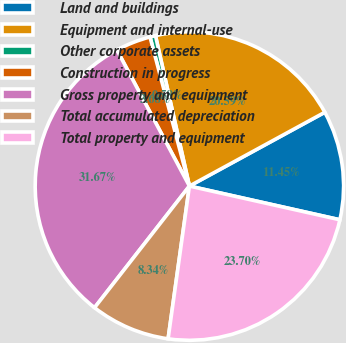Convert chart to OTSL. <chart><loc_0><loc_0><loc_500><loc_500><pie_chart><fcel>Land and buildings<fcel>Equipment and internal-use<fcel>Other corporate assets<fcel>Construction in progress<fcel>Gross property and equipment<fcel>Total accumulated depreciation<fcel>Total property and equipment<nl><fcel>11.45%<fcel>20.59%<fcel>0.58%<fcel>3.68%<fcel>31.67%<fcel>8.34%<fcel>23.7%<nl></chart> 